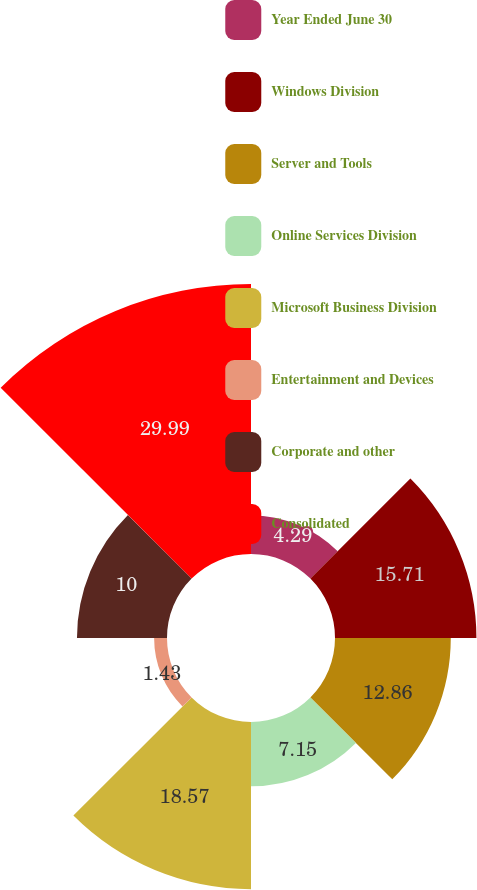Convert chart. <chart><loc_0><loc_0><loc_500><loc_500><pie_chart><fcel>Year Ended June 30<fcel>Windows Division<fcel>Server and Tools<fcel>Online Services Division<fcel>Microsoft Business Division<fcel>Entertainment and Devices<fcel>Corporate and other<fcel>Consolidated<nl><fcel>4.29%<fcel>15.71%<fcel>12.86%<fcel>7.15%<fcel>18.57%<fcel>1.43%<fcel>10.0%<fcel>29.99%<nl></chart> 